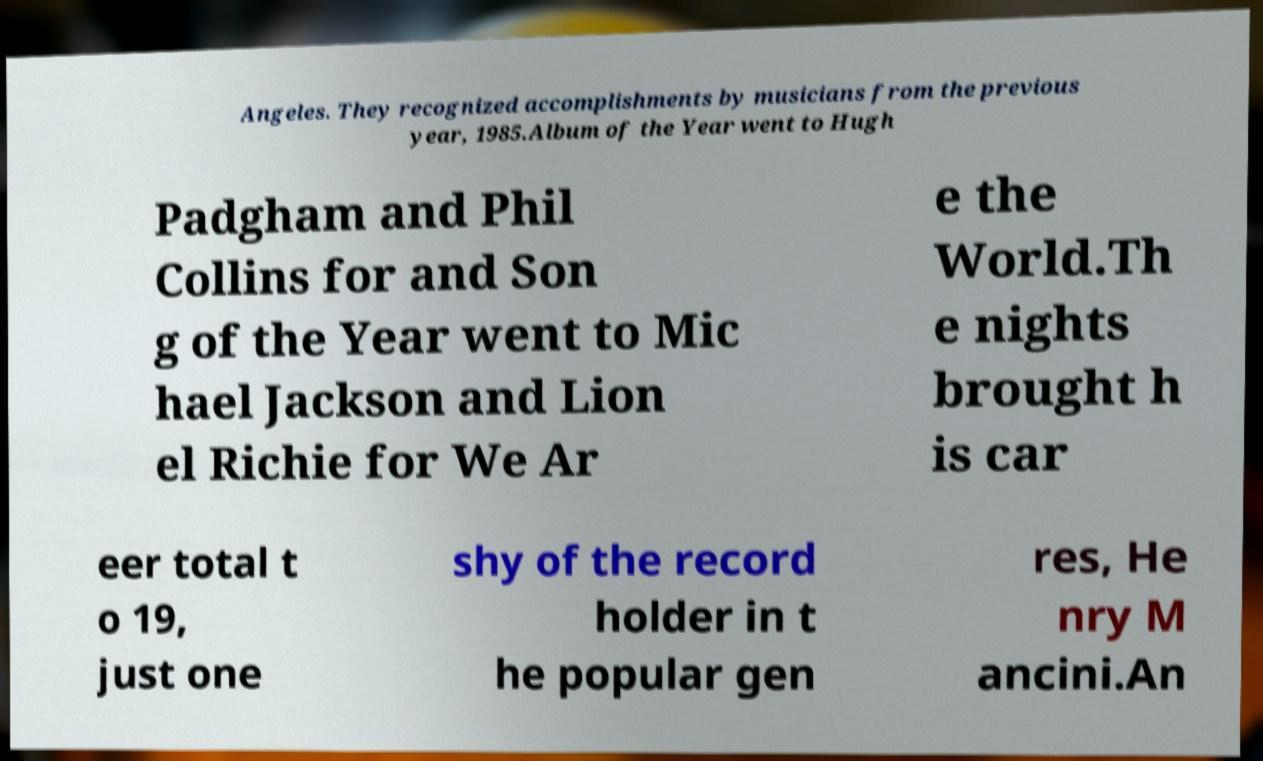I need the written content from this picture converted into text. Can you do that? Angeles. They recognized accomplishments by musicians from the previous year, 1985.Album of the Year went to Hugh Padgham and Phil Collins for and Son g of the Year went to Mic hael Jackson and Lion el Richie for We Ar e the World.Th e nights brought h is car eer total t o 19, just one shy of the record holder in t he popular gen res, He nry M ancini.An 